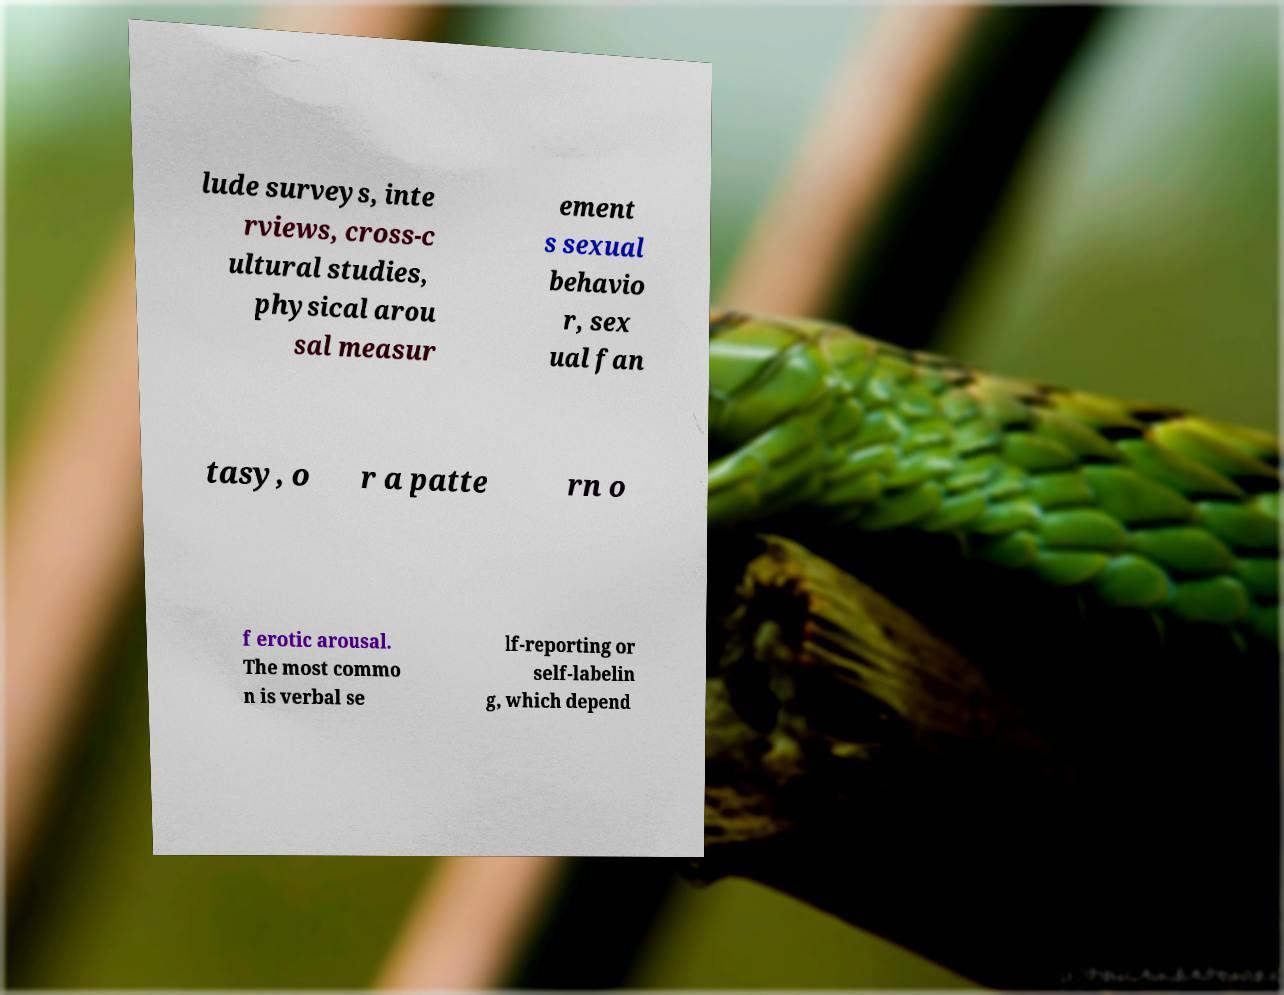There's text embedded in this image that I need extracted. Can you transcribe it verbatim? lude surveys, inte rviews, cross-c ultural studies, physical arou sal measur ement s sexual behavio r, sex ual fan tasy, o r a patte rn o f erotic arousal. The most commo n is verbal se lf-reporting or self-labelin g, which depend 